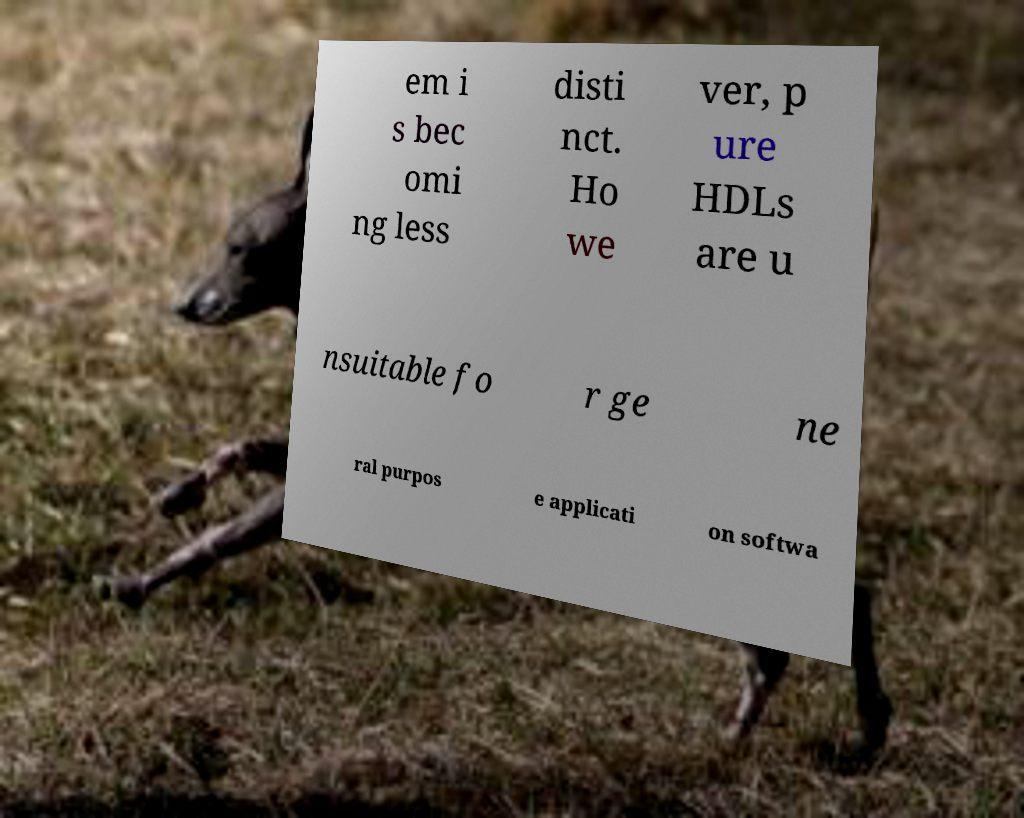Please read and relay the text visible in this image. What does it say? em i s bec omi ng less disti nct. Ho we ver, p ure HDLs are u nsuitable fo r ge ne ral purpos e applicati on softwa 